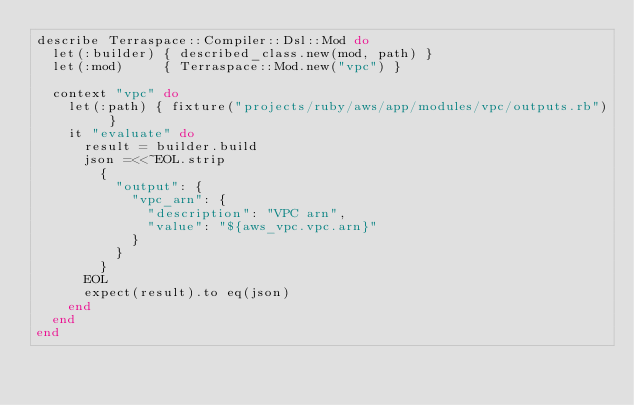Convert code to text. <code><loc_0><loc_0><loc_500><loc_500><_Ruby_>describe Terraspace::Compiler::Dsl::Mod do
  let(:builder) { described_class.new(mod, path) }
  let(:mod)     { Terraspace::Mod.new("vpc") }

  context "vpc" do
    let(:path) { fixture("projects/ruby/aws/app/modules/vpc/outputs.rb") }
    it "evaluate" do
      result = builder.build
      json =<<~EOL.strip
        {
          "output": {
            "vpc_arn": {
              "description": "VPC arn",
              "value": "${aws_vpc.vpc.arn}"
            }
          }
        }
      EOL
      expect(result).to eq(json)
    end
  end
end
</code> 